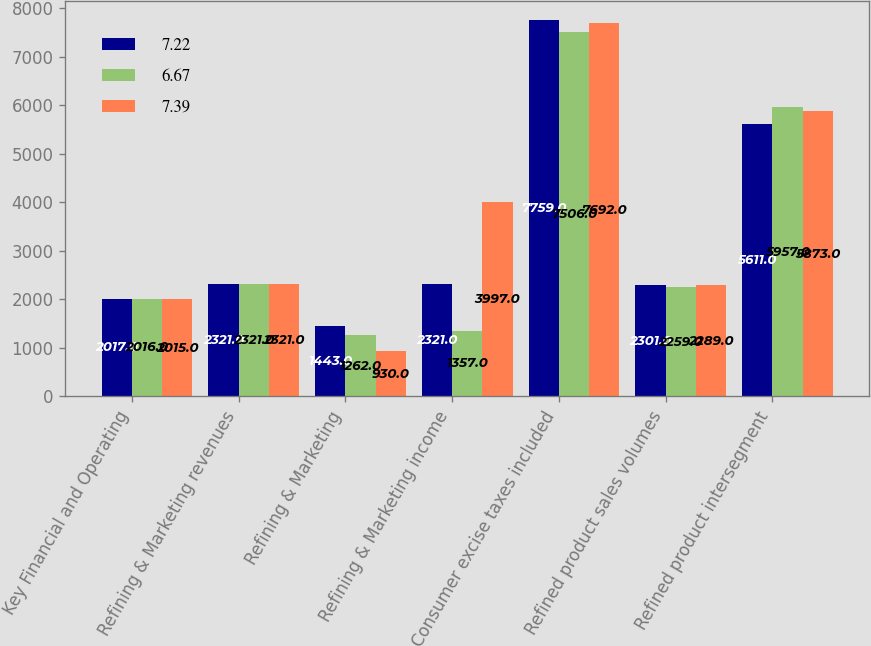<chart> <loc_0><loc_0><loc_500><loc_500><stacked_bar_chart><ecel><fcel>Key Financial and Operating<fcel>Refining & Marketing revenues<fcel>Refining & Marketing<fcel>Refining & Marketing income<fcel>Consumer excise taxes included<fcel>Refined product sales volumes<fcel>Refined product intersegment<nl><fcel>7.22<fcel>2017<fcel>2321<fcel>1443<fcel>2321<fcel>7759<fcel>2301<fcel>5611<nl><fcel>6.67<fcel>2016<fcel>2321<fcel>1262<fcel>1357<fcel>7506<fcel>2259<fcel>5957<nl><fcel>7.39<fcel>2015<fcel>2321<fcel>930<fcel>3997<fcel>7692<fcel>2289<fcel>5873<nl></chart> 